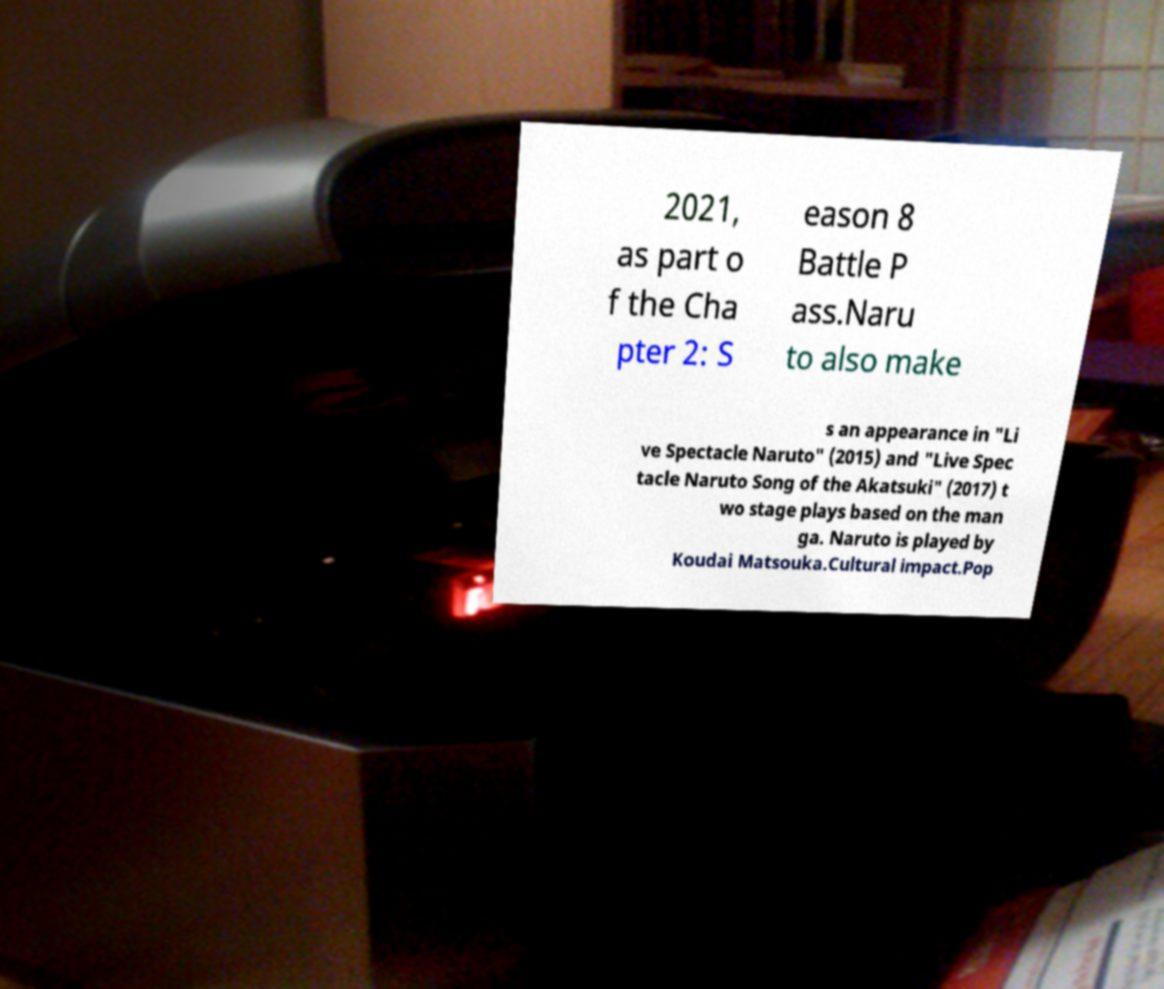Please read and relay the text visible in this image. What does it say? 2021, as part o f the Cha pter 2: S eason 8 Battle P ass.Naru to also make s an appearance in "Li ve Spectacle Naruto" (2015) and "Live Spec tacle Naruto Song of the Akatsuki" (2017) t wo stage plays based on the man ga. Naruto is played by Koudai Matsouka.Cultural impact.Pop 